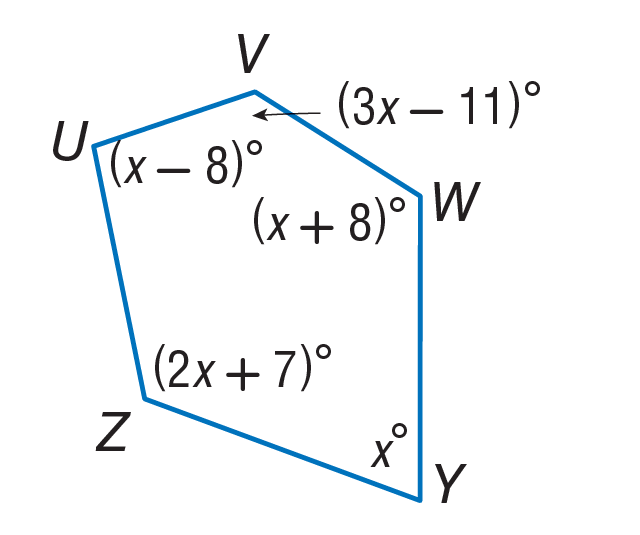Answer the mathemtical geometry problem and directly provide the correct option letter.
Question: Find m \angle V.
Choices: A: 34 B: 68 C: 193 D: 213 C 